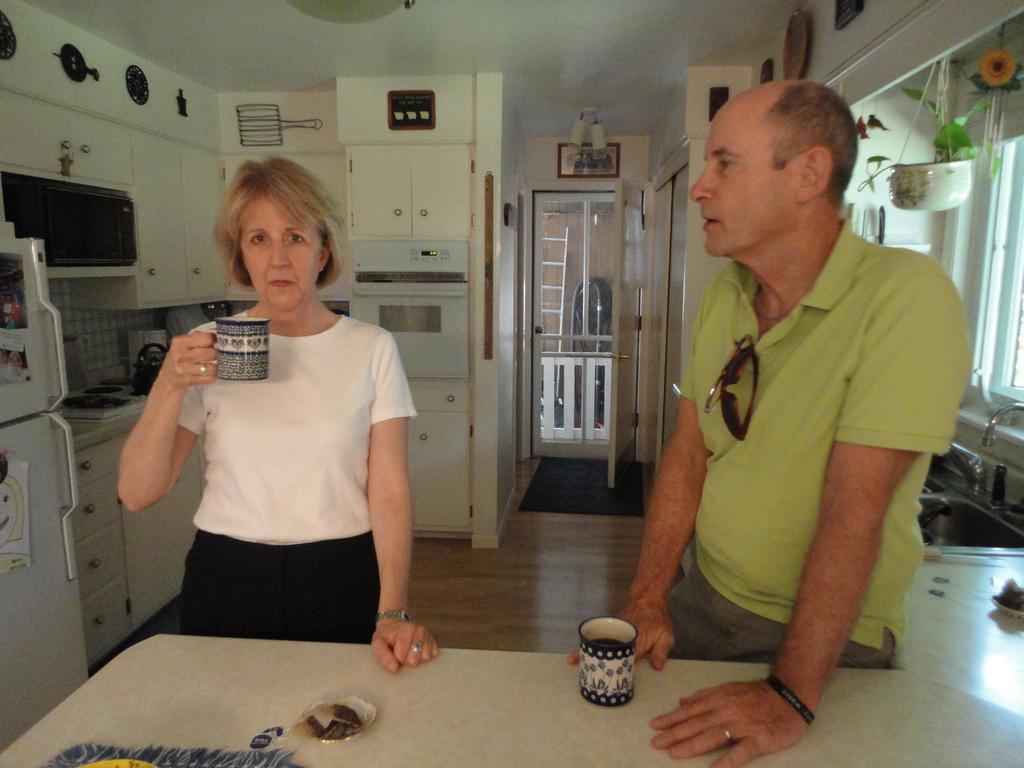Could you give a brief overview of what you see in this image? In this image there are two persons standing, there is a person holding a cup, there is a table truncated towards the bottom of the image, there is an object truncated towards the bottom of the image, there are objects on the table, there is an object truncated towards the right of the image, there is a tap truncated towards the right of the image, there is a tap truncated towards the right of the image, there is a window truncated towards the right of the image, there is the sink, there are plants, there is the wall, there are objects on the wall, there is the door, there is a ladder, there is an oven, there are shelves, there are objects, there is a refrigerator truncated towards the left of the image, there is a roof truncated towards the top of the image, there is an object truncated towards the top of the image. 